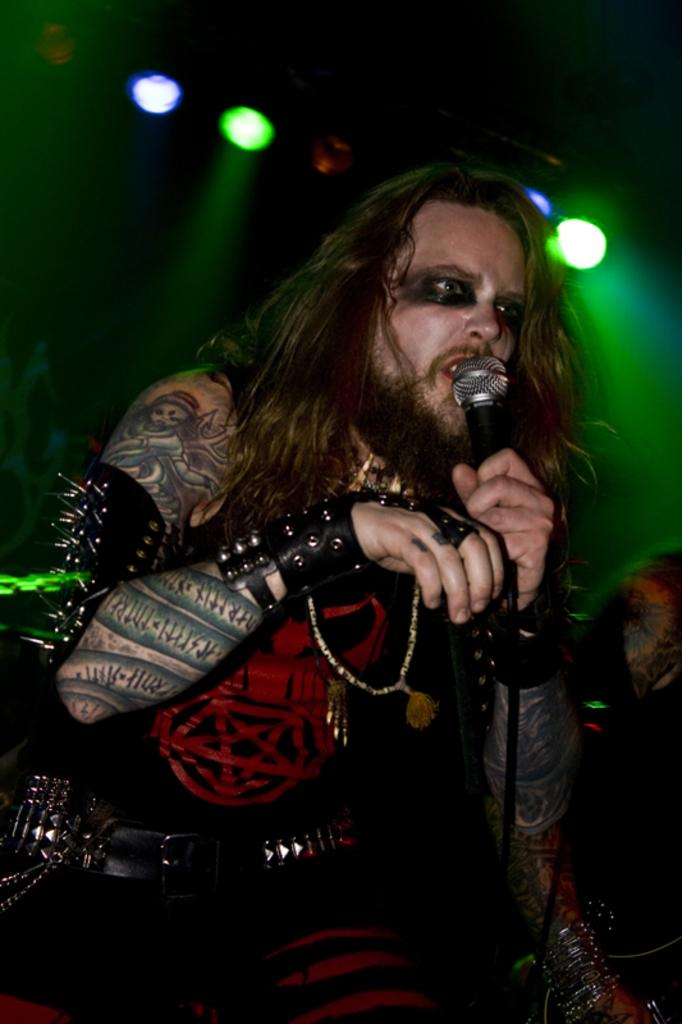Who is the main subject in the image? There is a man in the image. What is the man holding in his hand? The man is holding a mic in his hand. What can be seen in the background of the image? There are lightings visible in the image. What type of writing can be seen on the man's shirt in the image? There is no writing visible on the man's shirt in the image. What kind of thread is being used to sew the man's pants in the image? There is no information about the man's pants or the thread used to sew them in the image. 